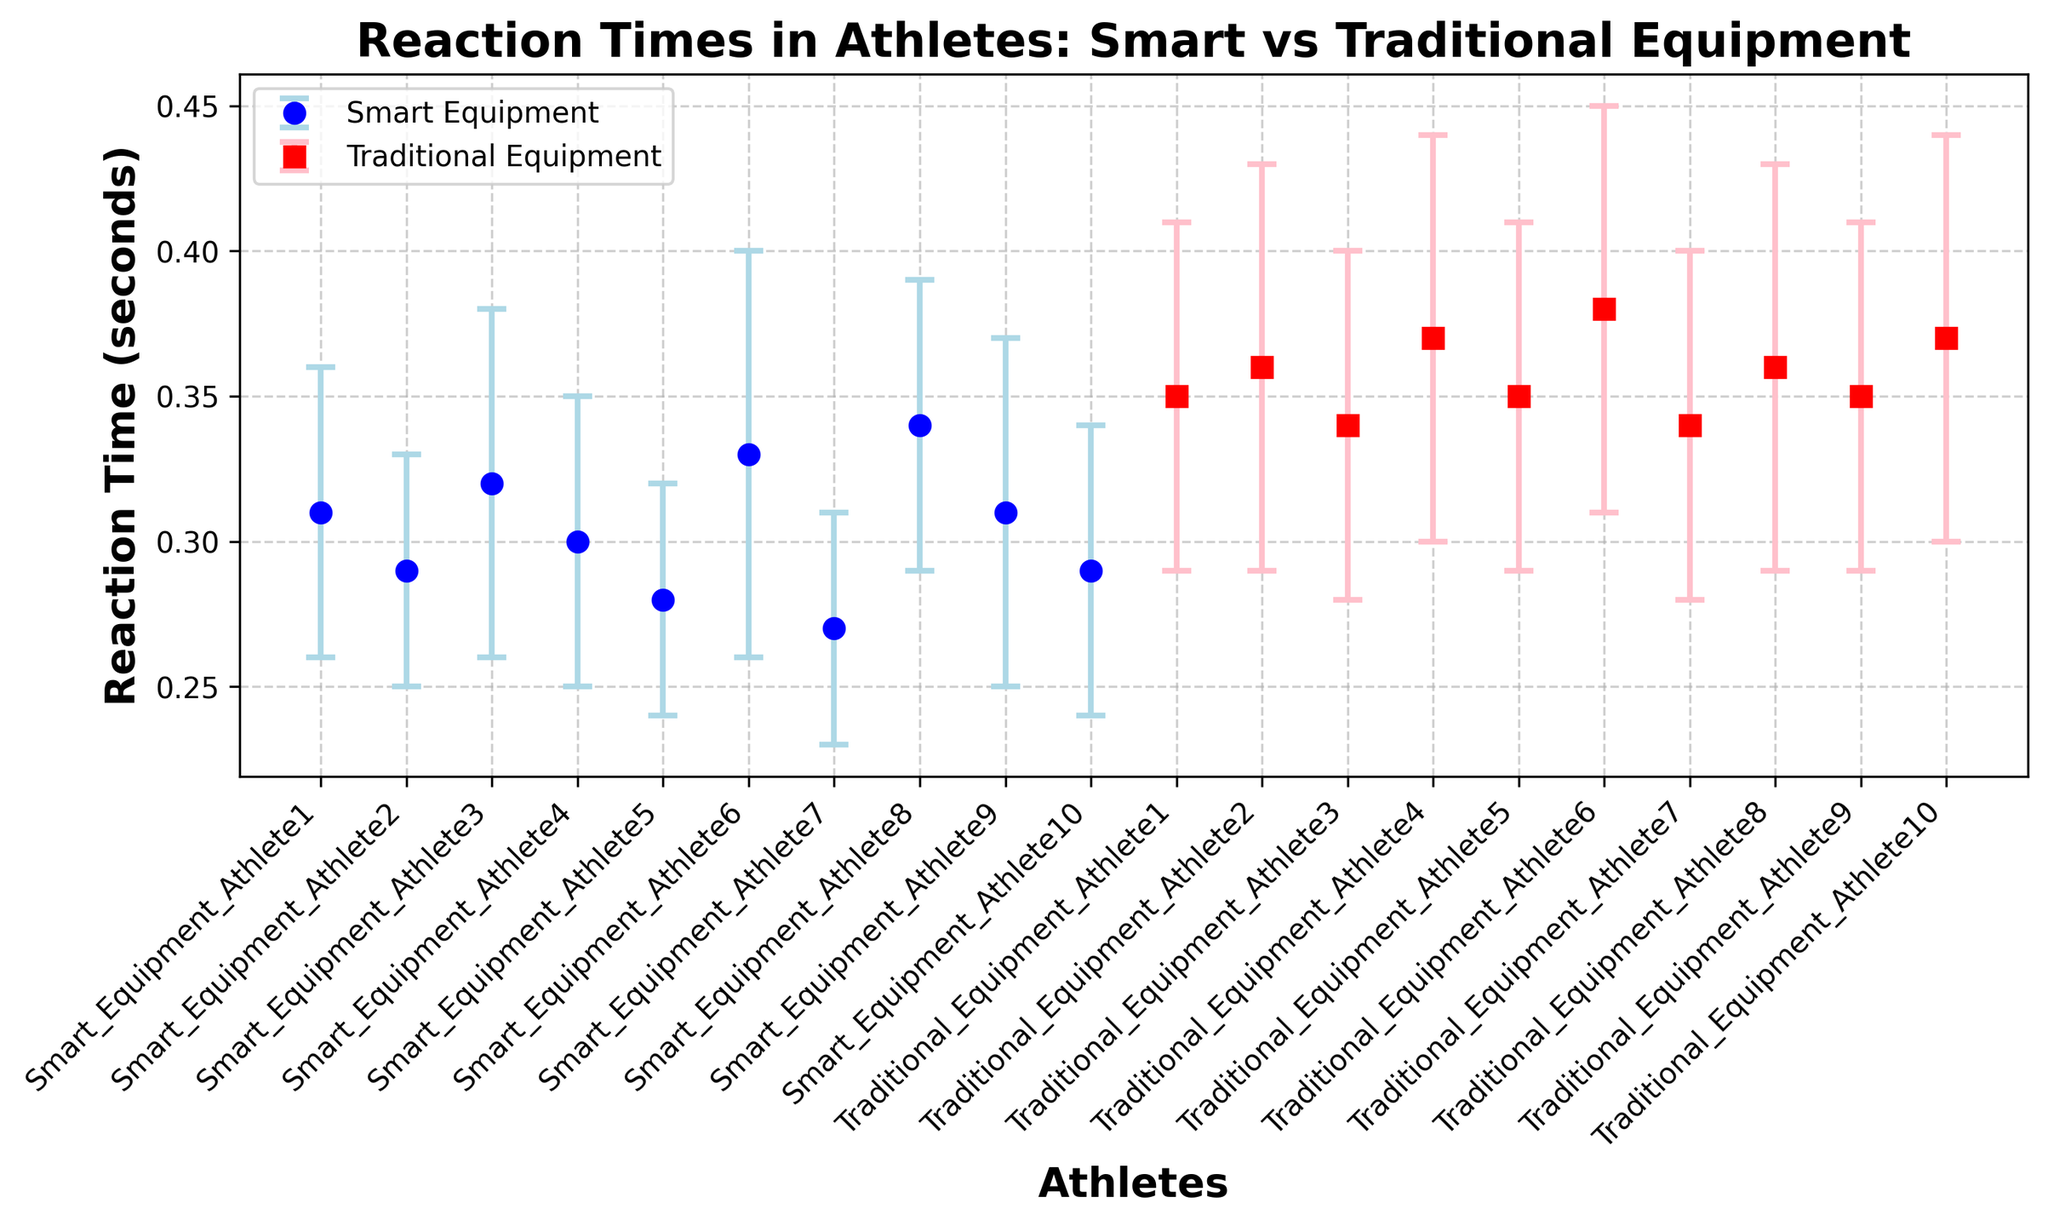Which group of athletes generally demonstrated faster reaction times? When comparing the mean reaction times, athletes using smart equipment generally have means in the range of 0.27 to 0.34 seconds, whereas athletes using traditional equipment have means ranging from 0.34 to 0.38 seconds. Therefore, smart equipment athletes consistently show faster reaction times.
Answer: Smart equipment athletes Which athlete had the fastest reaction time? By examining the means of reaction times, Athlete 7 using smart equipment had the lowest mean reaction time at 0.27 seconds.
Answer: Smart_Equipment_Athlete7 How does the variability of reaction times in athletes using traditional equipment compare to those using smart equipment? Standard deviations (Std) show variability. Traditional equipment athletes have stds from 0.06 to 0.07, while smart equipment athletes have stds from 0.04 to 0.07. Smart equipment athletes generally show less variability as their stds are lower on average.
Answer: Less variability in smart equipment athletes What is the average reaction time for athletes using smart equipment? Summing up the reaction time means for smart equipment athletes (0.31 + 0.29 + 0.32 + 0.30 + 0.28 + 0.33 + 0.27 + 0.34 + 0.31 + 0.29) gives 3.04. The average is 3.04 divided by 10, which is 0.304 seconds.
Answer: 0.304 seconds Are there any athletes with overlapping reaction times when comparing the two groups? Check the ranges of reaction times. Some smart equipment athletes with means around 0.31 and 0.32 overlap with traditional equipment athletes around 0.34 and 0.35 when considering their error margins (Std).
Answer: Yes Which athlete had the highest variability in their reaction time using smart equipment? Comparing the standard deviations of smart equipment athletes, Athlete 6 has the highest variability with a std of 0.07 seconds.
Answer: Smart_Equipment_Athlete6 What is the overall trend in reaction times when comparing smart and traditional equipment athletes? Generally, smart equipment athletes have lower and less variable reaction times, indicating a trend of improved speed and consistency compared to those using traditional equipment where reaction times are higher and more variable.
Answer: Faster and more consistent with smart equipment 